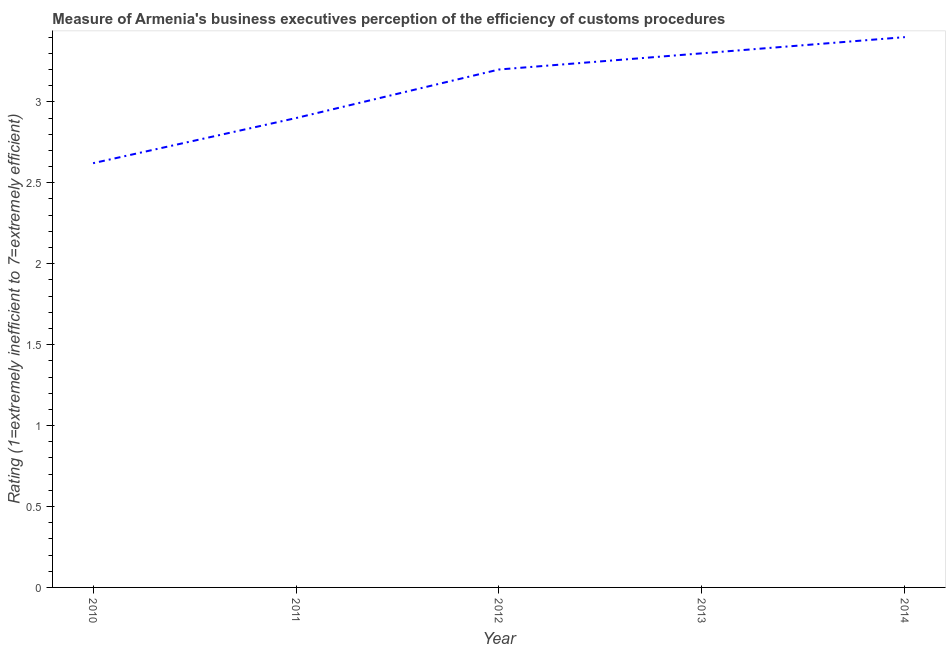Across all years, what is the maximum rating measuring burden of customs procedure?
Offer a very short reply. 3.4. Across all years, what is the minimum rating measuring burden of customs procedure?
Provide a short and direct response. 2.62. What is the sum of the rating measuring burden of customs procedure?
Make the answer very short. 15.42. What is the difference between the rating measuring burden of customs procedure in 2010 and 2013?
Your response must be concise. -0.68. What is the average rating measuring burden of customs procedure per year?
Your answer should be compact. 3.08. What is the median rating measuring burden of customs procedure?
Provide a succinct answer. 3.2. Do a majority of the years between 2010 and 2012 (inclusive) have rating measuring burden of customs procedure greater than 0.5 ?
Your answer should be compact. Yes. What is the ratio of the rating measuring burden of customs procedure in 2010 to that in 2013?
Make the answer very short. 0.79. Is the rating measuring burden of customs procedure in 2010 less than that in 2014?
Your answer should be very brief. Yes. Is the difference between the rating measuring burden of customs procedure in 2013 and 2014 greater than the difference between any two years?
Your answer should be compact. No. What is the difference between the highest and the second highest rating measuring burden of customs procedure?
Give a very brief answer. 0.1. What is the difference between the highest and the lowest rating measuring burden of customs procedure?
Ensure brevity in your answer.  0.78. Does the rating measuring burden of customs procedure monotonically increase over the years?
Make the answer very short. Yes. How many years are there in the graph?
Keep it short and to the point. 5. Does the graph contain grids?
Make the answer very short. No. What is the title of the graph?
Your answer should be very brief. Measure of Armenia's business executives perception of the efficiency of customs procedures. What is the label or title of the X-axis?
Offer a very short reply. Year. What is the label or title of the Y-axis?
Offer a very short reply. Rating (1=extremely inefficient to 7=extremely efficient). What is the Rating (1=extremely inefficient to 7=extremely efficient) in 2010?
Provide a succinct answer. 2.62. What is the Rating (1=extremely inefficient to 7=extremely efficient) of 2011?
Offer a very short reply. 2.9. What is the Rating (1=extremely inefficient to 7=extremely efficient) of 2012?
Give a very brief answer. 3.2. What is the Rating (1=extremely inefficient to 7=extremely efficient) of 2013?
Offer a very short reply. 3.3. What is the difference between the Rating (1=extremely inefficient to 7=extremely efficient) in 2010 and 2011?
Ensure brevity in your answer.  -0.28. What is the difference between the Rating (1=extremely inefficient to 7=extremely efficient) in 2010 and 2012?
Ensure brevity in your answer.  -0.58. What is the difference between the Rating (1=extremely inefficient to 7=extremely efficient) in 2010 and 2013?
Your answer should be very brief. -0.68. What is the difference between the Rating (1=extremely inefficient to 7=extremely efficient) in 2010 and 2014?
Ensure brevity in your answer.  -0.78. What is the difference between the Rating (1=extremely inefficient to 7=extremely efficient) in 2011 and 2014?
Offer a terse response. -0.5. What is the difference between the Rating (1=extremely inefficient to 7=extremely efficient) in 2012 and 2013?
Your answer should be compact. -0.1. What is the ratio of the Rating (1=extremely inefficient to 7=extremely efficient) in 2010 to that in 2011?
Keep it short and to the point. 0.9. What is the ratio of the Rating (1=extremely inefficient to 7=extremely efficient) in 2010 to that in 2012?
Keep it short and to the point. 0.82. What is the ratio of the Rating (1=extremely inefficient to 7=extremely efficient) in 2010 to that in 2013?
Your response must be concise. 0.79. What is the ratio of the Rating (1=extremely inefficient to 7=extremely efficient) in 2010 to that in 2014?
Make the answer very short. 0.77. What is the ratio of the Rating (1=extremely inefficient to 7=extremely efficient) in 2011 to that in 2012?
Offer a very short reply. 0.91. What is the ratio of the Rating (1=extremely inefficient to 7=extremely efficient) in 2011 to that in 2013?
Provide a succinct answer. 0.88. What is the ratio of the Rating (1=extremely inefficient to 7=extremely efficient) in 2011 to that in 2014?
Provide a succinct answer. 0.85. What is the ratio of the Rating (1=extremely inefficient to 7=extremely efficient) in 2012 to that in 2014?
Provide a short and direct response. 0.94. What is the ratio of the Rating (1=extremely inefficient to 7=extremely efficient) in 2013 to that in 2014?
Your answer should be compact. 0.97. 